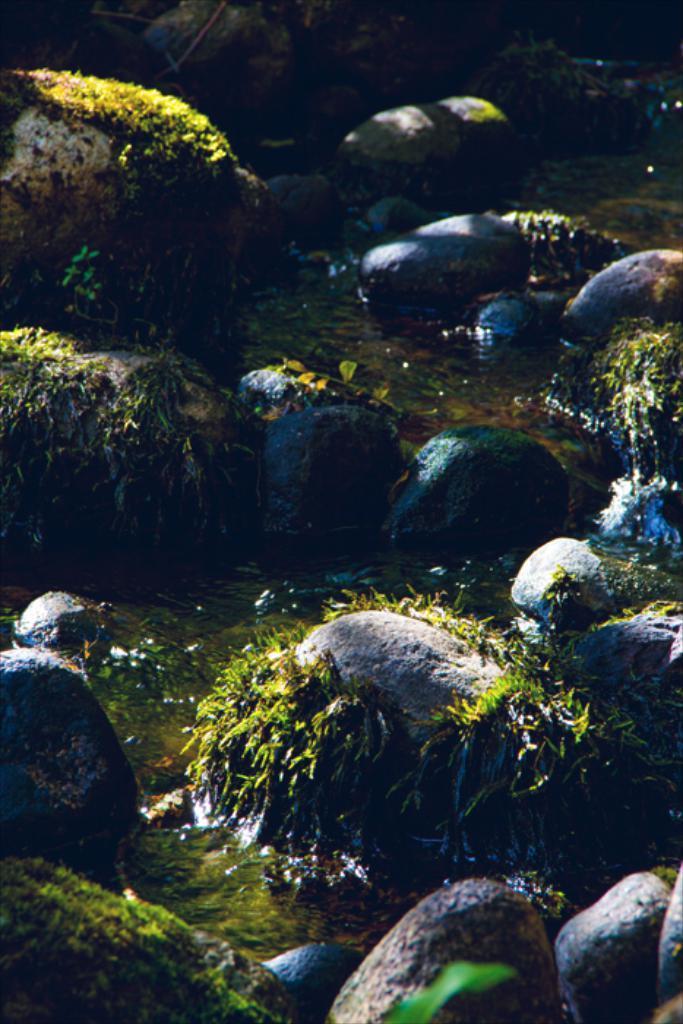In one or two sentences, can you explain what this image depicts? In the foreground I can see rocks, grass and water. This image is taken may be in the river. 